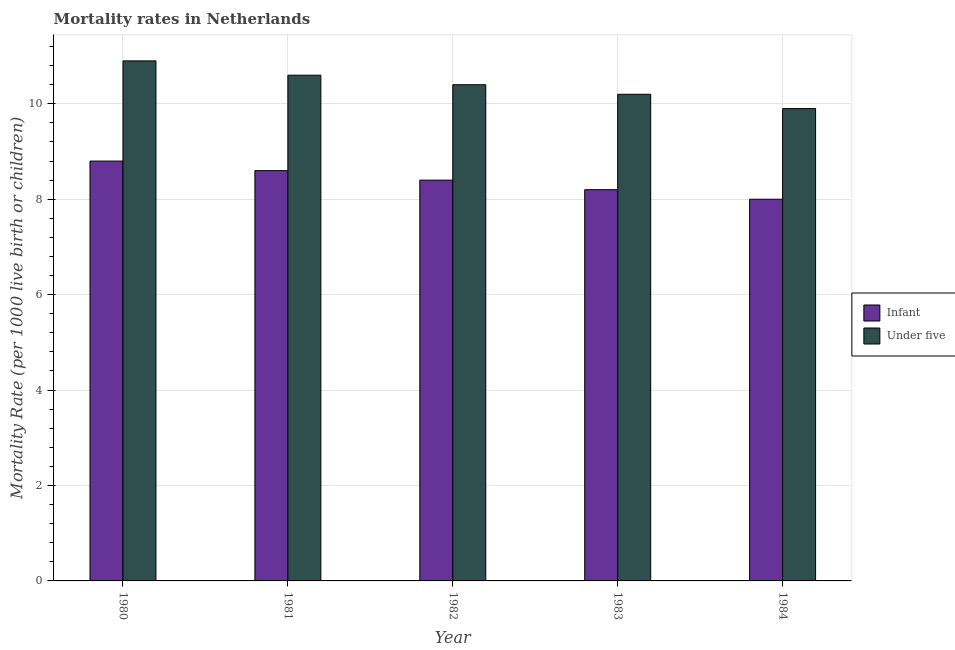How many different coloured bars are there?
Give a very brief answer. 2. How many groups of bars are there?
Your answer should be compact. 5. Are the number of bars on each tick of the X-axis equal?
Your answer should be very brief. Yes. What is the label of the 2nd group of bars from the left?
Give a very brief answer. 1981. In how many cases, is the number of bars for a given year not equal to the number of legend labels?
Provide a short and direct response. 0. In which year was the infant mortality rate minimum?
Provide a short and direct response. 1984. What is the total infant mortality rate in the graph?
Provide a short and direct response. 42. What is the difference between the under-5 mortality rate in 1981 and that in 1984?
Ensure brevity in your answer.  0.7. What is the difference between the under-5 mortality rate in 1984 and the infant mortality rate in 1983?
Give a very brief answer. -0.3. In the year 1981, what is the difference between the under-5 mortality rate and infant mortality rate?
Offer a terse response. 0. What is the ratio of the under-5 mortality rate in 1980 to that in 1984?
Offer a very short reply. 1.1. Is the difference between the under-5 mortality rate in 1980 and 1984 greater than the difference between the infant mortality rate in 1980 and 1984?
Your answer should be very brief. No. What is the difference between the highest and the second highest infant mortality rate?
Keep it short and to the point. 0.2. What is the difference between the highest and the lowest infant mortality rate?
Make the answer very short. 0.8. In how many years, is the infant mortality rate greater than the average infant mortality rate taken over all years?
Offer a very short reply. 2. What does the 2nd bar from the left in 1982 represents?
Give a very brief answer. Under five. What does the 1st bar from the right in 1981 represents?
Offer a very short reply. Under five. Are the values on the major ticks of Y-axis written in scientific E-notation?
Provide a short and direct response. No. Does the graph contain any zero values?
Provide a succinct answer. No. Does the graph contain grids?
Ensure brevity in your answer.  Yes. Where does the legend appear in the graph?
Offer a very short reply. Center right. How many legend labels are there?
Give a very brief answer. 2. What is the title of the graph?
Your response must be concise. Mortality rates in Netherlands. What is the label or title of the Y-axis?
Your answer should be very brief. Mortality Rate (per 1000 live birth or children). What is the Mortality Rate (per 1000 live birth or children) in Infant in 1980?
Offer a terse response. 8.8. What is the Mortality Rate (per 1000 live birth or children) in Under five in 1980?
Offer a very short reply. 10.9. What is the Mortality Rate (per 1000 live birth or children) in Infant in 1981?
Ensure brevity in your answer.  8.6. What is the Mortality Rate (per 1000 live birth or children) of Under five in 1981?
Keep it short and to the point. 10.6. What is the Mortality Rate (per 1000 live birth or children) of Under five in 1982?
Ensure brevity in your answer.  10.4. What is the Mortality Rate (per 1000 live birth or children) of Under five in 1983?
Your response must be concise. 10.2. Across all years, what is the minimum Mortality Rate (per 1000 live birth or children) of Under five?
Provide a succinct answer. 9.9. What is the total Mortality Rate (per 1000 live birth or children) of Under five in the graph?
Keep it short and to the point. 52. What is the difference between the Mortality Rate (per 1000 live birth or children) in Under five in 1980 and that in 1981?
Provide a short and direct response. 0.3. What is the difference between the Mortality Rate (per 1000 live birth or children) in Infant in 1980 and that in 1982?
Provide a short and direct response. 0.4. What is the difference between the Mortality Rate (per 1000 live birth or children) in Under five in 1980 and that in 1982?
Provide a short and direct response. 0.5. What is the difference between the Mortality Rate (per 1000 live birth or children) of Under five in 1980 and that in 1983?
Your response must be concise. 0.7. What is the difference between the Mortality Rate (per 1000 live birth or children) in Infant in 1981 and that in 1982?
Give a very brief answer. 0.2. What is the difference between the Mortality Rate (per 1000 live birth or children) of Under five in 1981 and that in 1982?
Offer a very short reply. 0.2. What is the difference between the Mortality Rate (per 1000 live birth or children) in Infant in 1981 and that in 1983?
Offer a very short reply. 0.4. What is the difference between the Mortality Rate (per 1000 live birth or children) in Under five in 1981 and that in 1983?
Make the answer very short. 0.4. What is the difference between the Mortality Rate (per 1000 live birth or children) in Infant in 1981 and that in 1984?
Make the answer very short. 0.6. What is the difference between the Mortality Rate (per 1000 live birth or children) of Infant in 1983 and that in 1984?
Keep it short and to the point. 0.2. What is the difference between the Mortality Rate (per 1000 live birth or children) of Infant in 1980 and the Mortality Rate (per 1000 live birth or children) of Under five in 1982?
Keep it short and to the point. -1.6. What is the difference between the Mortality Rate (per 1000 live birth or children) of Infant in 1982 and the Mortality Rate (per 1000 live birth or children) of Under five in 1984?
Provide a succinct answer. -1.5. What is the difference between the Mortality Rate (per 1000 live birth or children) of Infant in 1983 and the Mortality Rate (per 1000 live birth or children) of Under five in 1984?
Ensure brevity in your answer.  -1.7. What is the average Mortality Rate (per 1000 live birth or children) of Under five per year?
Offer a terse response. 10.4. In the year 1980, what is the difference between the Mortality Rate (per 1000 live birth or children) of Infant and Mortality Rate (per 1000 live birth or children) of Under five?
Offer a very short reply. -2.1. In the year 1981, what is the difference between the Mortality Rate (per 1000 live birth or children) in Infant and Mortality Rate (per 1000 live birth or children) in Under five?
Offer a terse response. -2. In the year 1982, what is the difference between the Mortality Rate (per 1000 live birth or children) of Infant and Mortality Rate (per 1000 live birth or children) of Under five?
Ensure brevity in your answer.  -2. In the year 1984, what is the difference between the Mortality Rate (per 1000 live birth or children) of Infant and Mortality Rate (per 1000 live birth or children) of Under five?
Your response must be concise. -1.9. What is the ratio of the Mortality Rate (per 1000 live birth or children) in Infant in 1980 to that in 1981?
Offer a terse response. 1.02. What is the ratio of the Mortality Rate (per 1000 live birth or children) of Under five in 1980 to that in 1981?
Your answer should be very brief. 1.03. What is the ratio of the Mortality Rate (per 1000 live birth or children) in Infant in 1980 to that in 1982?
Offer a terse response. 1.05. What is the ratio of the Mortality Rate (per 1000 live birth or children) in Under five in 1980 to that in 1982?
Your answer should be very brief. 1.05. What is the ratio of the Mortality Rate (per 1000 live birth or children) of Infant in 1980 to that in 1983?
Your answer should be compact. 1.07. What is the ratio of the Mortality Rate (per 1000 live birth or children) of Under five in 1980 to that in 1983?
Your answer should be very brief. 1.07. What is the ratio of the Mortality Rate (per 1000 live birth or children) in Infant in 1980 to that in 1984?
Provide a succinct answer. 1.1. What is the ratio of the Mortality Rate (per 1000 live birth or children) of Under five in 1980 to that in 1984?
Provide a succinct answer. 1.1. What is the ratio of the Mortality Rate (per 1000 live birth or children) of Infant in 1981 to that in 1982?
Ensure brevity in your answer.  1.02. What is the ratio of the Mortality Rate (per 1000 live birth or children) in Under five in 1981 to that in 1982?
Provide a succinct answer. 1.02. What is the ratio of the Mortality Rate (per 1000 live birth or children) of Infant in 1981 to that in 1983?
Make the answer very short. 1.05. What is the ratio of the Mortality Rate (per 1000 live birth or children) in Under five in 1981 to that in 1983?
Offer a very short reply. 1.04. What is the ratio of the Mortality Rate (per 1000 live birth or children) of Infant in 1981 to that in 1984?
Your answer should be very brief. 1.07. What is the ratio of the Mortality Rate (per 1000 live birth or children) in Under five in 1981 to that in 1984?
Make the answer very short. 1.07. What is the ratio of the Mortality Rate (per 1000 live birth or children) in Infant in 1982 to that in 1983?
Provide a short and direct response. 1.02. What is the ratio of the Mortality Rate (per 1000 live birth or children) of Under five in 1982 to that in 1983?
Keep it short and to the point. 1.02. What is the ratio of the Mortality Rate (per 1000 live birth or children) in Under five in 1982 to that in 1984?
Make the answer very short. 1.05. What is the ratio of the Mortality Rate (per 1000 live birth or children) in Infant in 1983 to that in 1984?
Provide a short and direct response. 1.02. What is the ratio of the Mortality Rate (per 1000 live birth or children) in Under five in 1983 to that in 1984?
Offer a terse response. 1.03. What is the difference between the highest and the second highest Mortality Rate (per 1000 live birth or children) of Infant?
Your response must be concise. 0.2. What is the difference between the highest and the lowest Mortality Rate (per 1000 live birth or children) in Under five?
Offer a terse response. 1. 